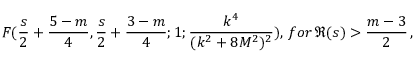<formula> <loc_0><loc_0><loc_500><loc_500>F ( \frac { s } { 2 } + \frac { 5 - m } { 4 } , \frac { s } { 2 } + \frac { 3 - m } { 4 } ; 1 ; \frac { k ^ { 4 } } { ( k ^ { 2 } + 8 M ^ { 2 } ) ^ { 2 } } ) , \, f o r \, \Re ( s ) > \frac { m - 3 } { 2 } \, ,</formula> 